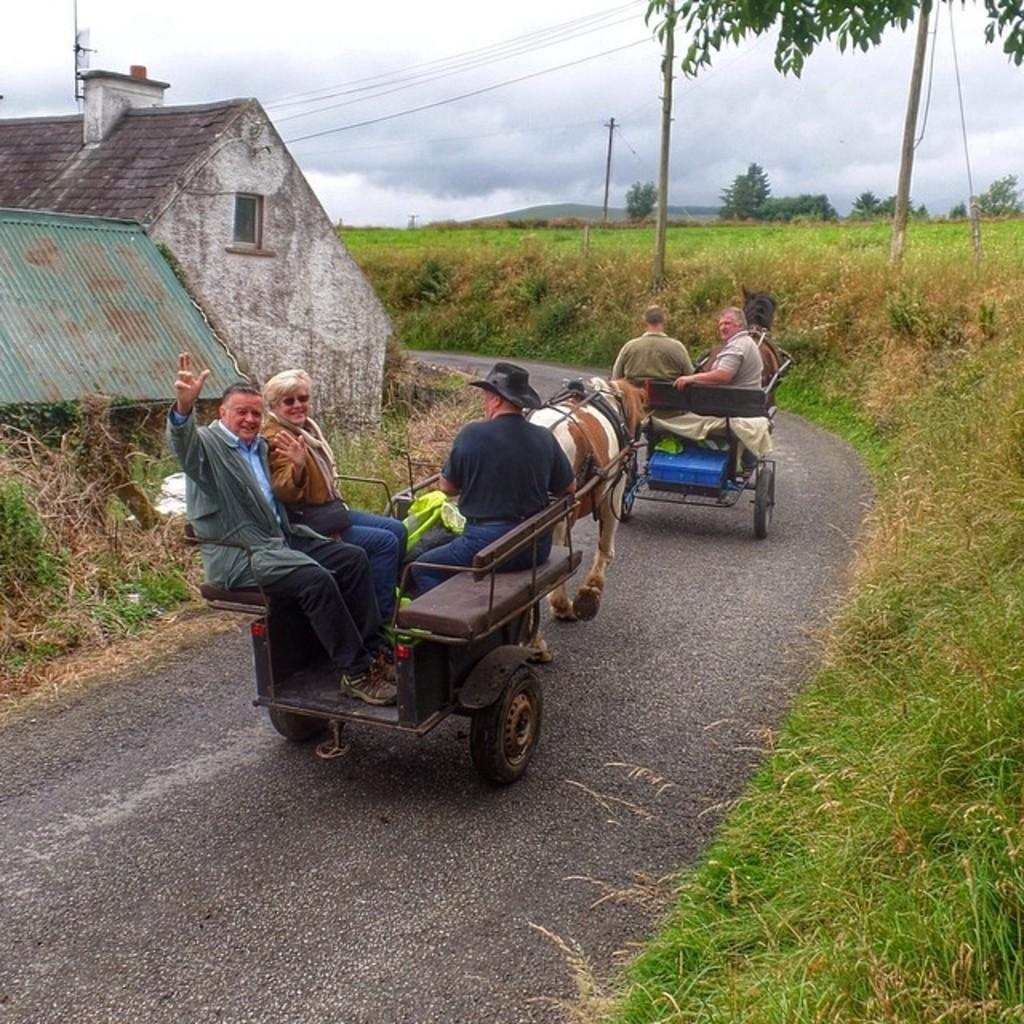What type of surface can be seen in the image? There is a road in the image. What type of structure is visible in the image? There is a house in the image. What type of vegetation is present in the image? Grass and trees are present in the image. What activity is taking place in the image? There are people sitting behind a horse in the image. How does the pollution affect the holiday atmosphere in the image? There is no mention of pollution or a holiday atmosphere in the image, so it is not possible to answer that question. 